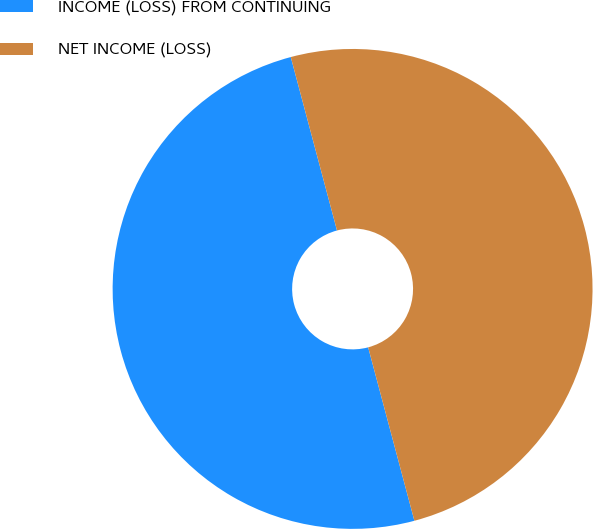<chart> <loc_0><loc_0><loc_500><loc_500><pie_chart><fcel>INCOME (LOSS) FROM CONTINUING<fcel>NET INCOME (LOSS)<nl><fcel>50.0%<fcel>50.0%<nl></chart> 